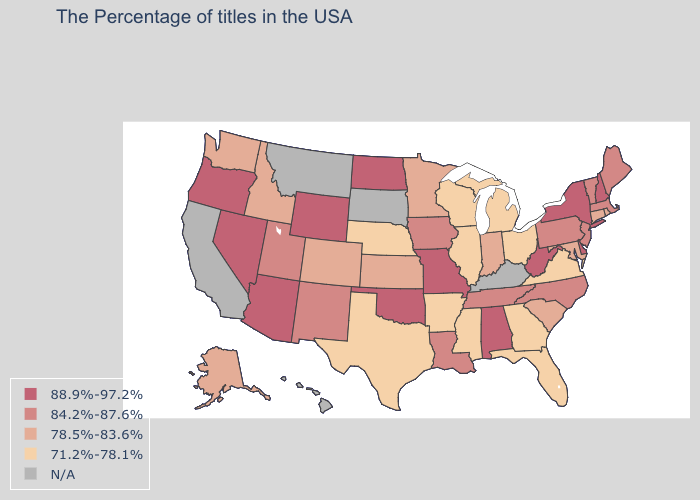How many symbols are there in the legend?
Be succinct. 5. What is the lowest value in states that border New Hampshire?
Be succinct. 84.2%-87.6%. What is the value of Georgia?
Quick response, please. 71.2%-78.1%. Which states have the highest value in the USA?
Quick response, please. New Hampshire, New York, Delaware, West Virginia, Alabama, Missouri, Oklahoma, North Dakota, Wyoming, Arizona, Nevada, Oregon. Does the map have missing data?
Answer briefly. Yes. Name the states that have a value in the range 84.2%-87.6%?
Write a very short answer. Maine, Massachusetts, Vermont, New Jersey, Pennsylvania, North Carolina, Tennessee, Louisiana, Iowa, New Mexico, Utah. How many symbols are there in the legend?
Concise answer only. 5. Does the map have missing data?
Write a very short answer. Yes. What is the value of Wisconsin?
Answer briefly. 71.2%-78.1%. Does Wyoming have the highest value in the West?
Be succinct. Yes. Among the states that border West Virginia , which have the lowest value?
Concise answer only. Virginia, Ohio. What is the value of Pennsylvania?
Concise answer only. 84.2%-87.6%. What is the lowest value in states that border New Mexico?
Be succinct. 71.2%-78.1%. Among the states that border Colorado , does Utah have the lowest value?
Quick response, please. No. Does Rhode Island have the lowest value in the Northeast?
Quick response, please. Yes. 